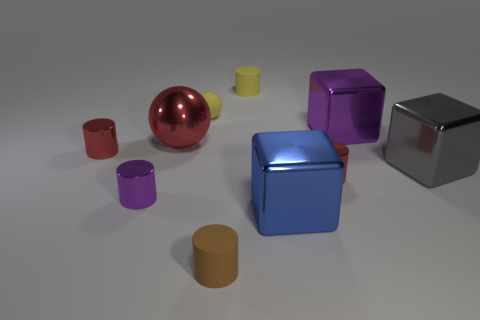Is the color of the metallic cylinder that is on the right side of the red metal ball the same as the rubber object that is to the left of the small brown matte thing?
Keep it short and to the point. No. Is the number of big red metal objects right of the red sphere less than the number of yellow objects that are in front of the small brown cylinder?
Make the answer very short. No. The purple shiny object that is in front of the purple metal block has what shape?
Offer a terse response. Cylinder. There is a small cylinder that is the same color as the tiny ball; what material is it?
Give a very brief answer. Rubber. What number of other things are made of the same material as the large purple thing?
Provide a short and direct response. 6. There is a small brown thing; is it the same shape as the tiny red object on the left side of the blue object?
Ensure brevity in your answer.  Yes. What is the shape of the big gray object that is made of the same material as the blue cube?
Provide a succinct answer. Cube. Is the number of yellow matte spheres that are in front of the gray block greater than the number of tiny red cylinders behind the large purple metal object?
Give a very brief answer. No. How many objects are blue metallic things or small things?
Give a very brief answer. 7. How many other things are the same color as the tiny sphere?
Offer a very short reply. 1. 